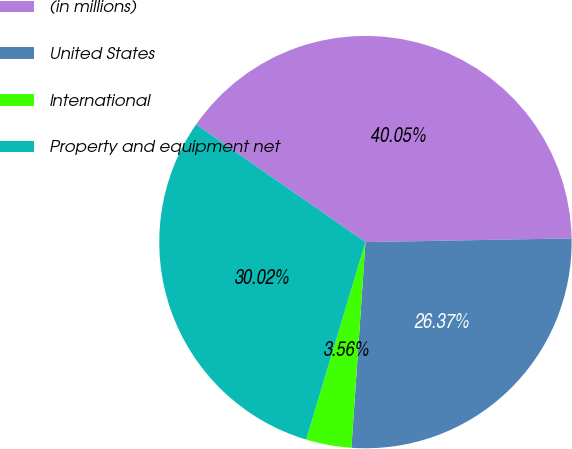Convert chart to OTSL. <chart><loc_0><loc_0><loc_500><loc_500><pie_chart><fcel>(in millions)<fcel>United States<fcel>International<fcel>Property and equipment net<nl><fcel>40.05%<fcel>26.37%<fcel>3.56%<fcel>30.02%<nl></chart> 